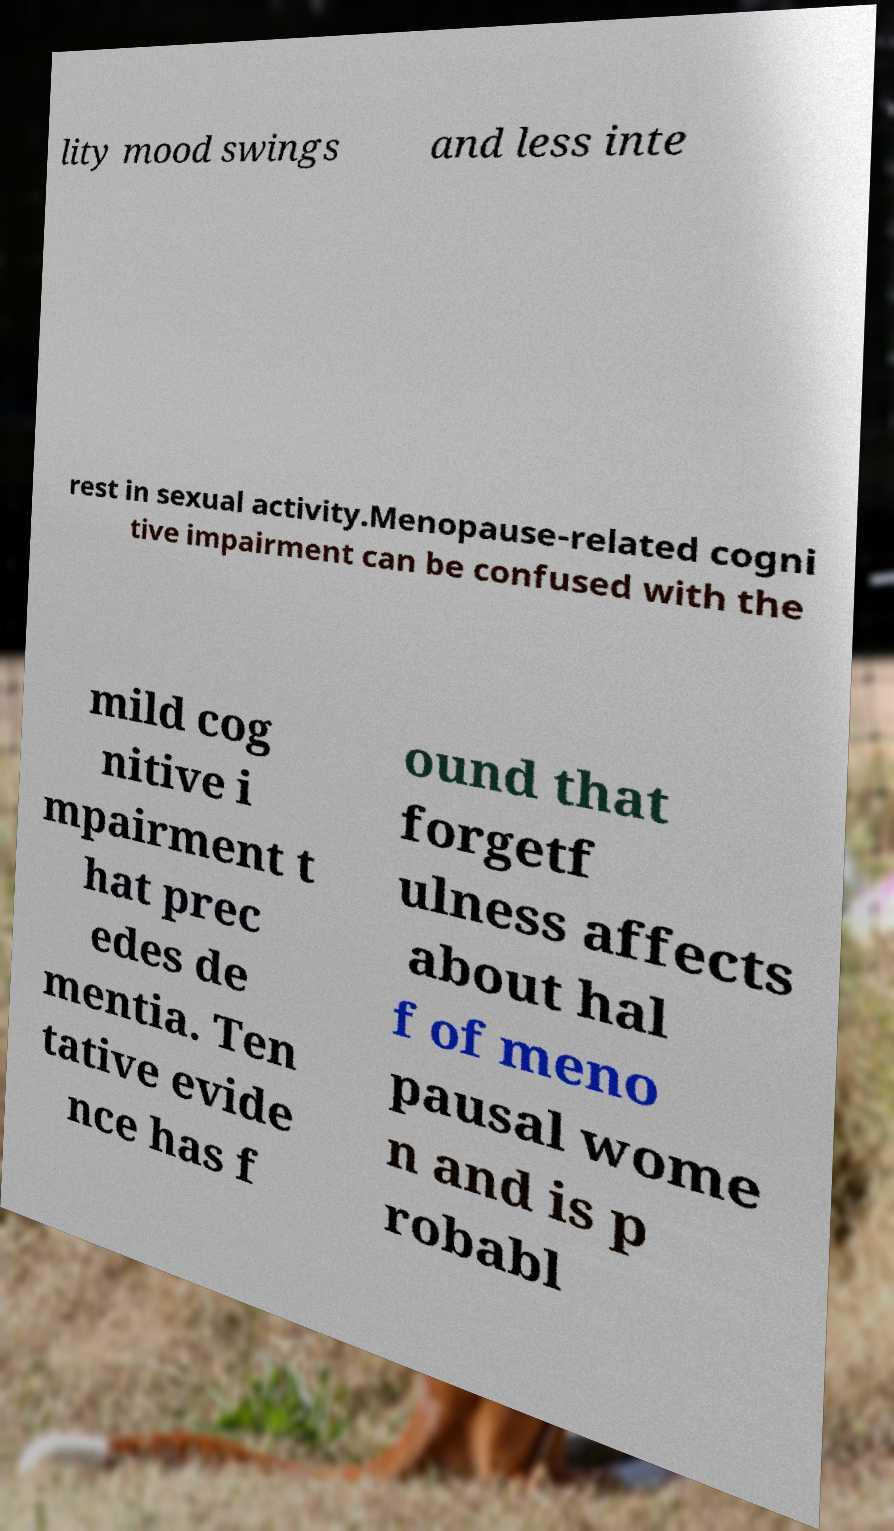I need the written content from this picture converted into text. Can you do that? lity mood swings and less inte rest in sexual activity.Menopause-related cogni tive impairment can be confused with the mild cog nitive i mpairment t hat prec edes de mentia. Ten tative evide nce has f ound that forgetf ulness affects about hal f of meno pausal wome n and is p robabl 